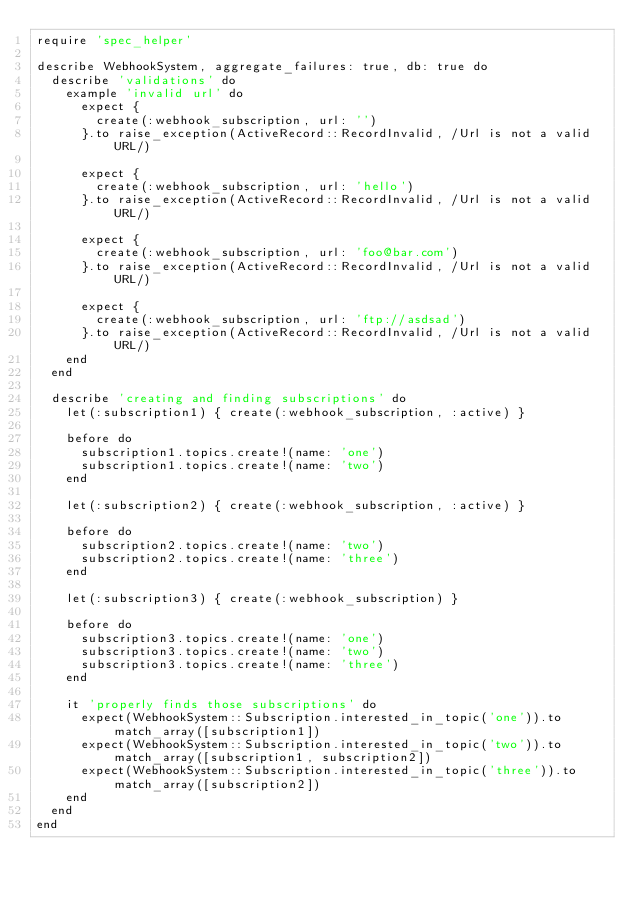Convert code to text. <code><loc_0><loc_0><loc_500><loc_500><_Ruby_>require 'spec_helper'

describe WebhookSystem, aggregate_failures: true, db: true do
  describe 'validations' do
    example 'invalid url' do
      expect {
        create(:webhook_subscription, url: '')
      }.to raise_exception(ActiveRecord::RecordInvalid, /Url is not a valid URL/)

      expect {
        create(:webhook_subscription, url: 'hello')
      }.to raise_exception(ActiveRecord::RecordInvalid, /Url is not a valid URL/)

      expect {
        create(:webhook_subscription, url: 'foo@bar.com')
      }.to raise_exception(ActiveRecord::RecordInvalid, /Url is not a valid URL/)

      expect {
        create(:webhook_subscription, url: 'ftp://asdsad')
      }.to raise_exception(ActiveRecord::RecordInvalid, /Url is not a valid URL/)
    end
  end

  describe 'creating and finding subscriptions' do
    let(:subscription1) { create(:webhook_subscription, :active) }

    before do
      subscription1.topics.create!(name: 'one')
      subscription1.topics.create!(name: 'two')
    end

    let(:subscription2) { create(:webhook_subscription, :active) }

    before do
      subscription2.topics.create!(name: 'two')
      subscription2.topics.create!(name: 'three')
    end

    let(:subscription3) { create(:webhook_subscription) }

    before do
      subscription3.topics.create!(name: 'one')
      subscription3.topics.create!(name: 'two')
      subscription3.topics.create!(name: 'three')
    end

    it 'properly finds those subscriptions' do
      expect(WebhookSystem::Subscription.interested_in_topic('one')).to match_array([subscription1])
      expect(WebhookSystem::Subscription.interested_in_topic('two')).to match_array([subscription1, subscription2])
      expect(WebhookSystem::Subscription.interested_in_topic('three')).to match_array([subscription2])
    end
  end
end
</code> 